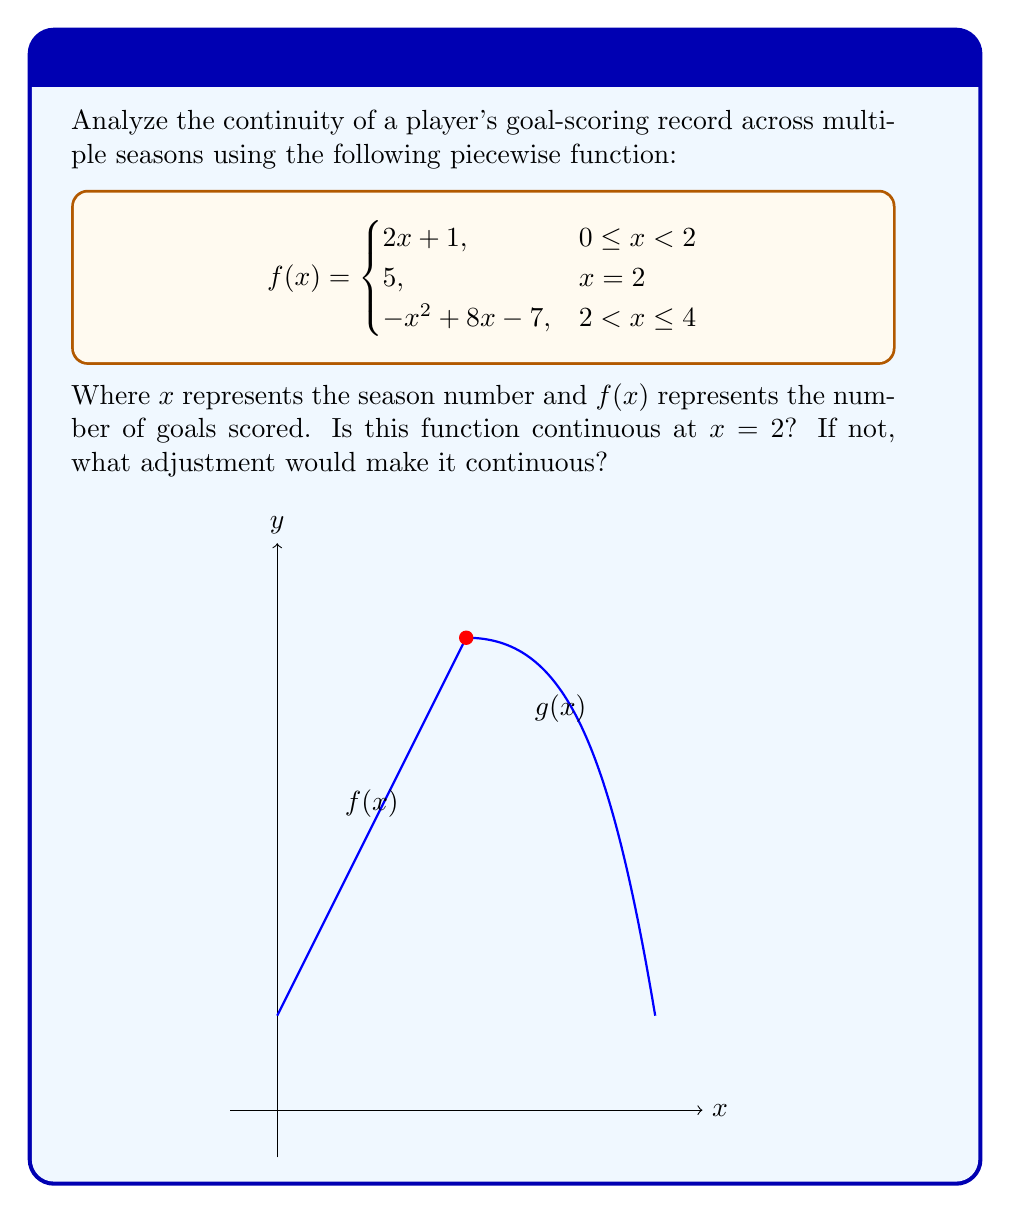Can you solve this math problem? To analyze the continuity at $x = 2$, we need to check three conditions:

1) $f(2)$ exists
2) $\lim_{x \to 2^-} f(x)$ exists
3) $\lim_{x \to 2^+} f(x)$ exists
4) All three values are equal

Step 1: $f(2)$ exists and equals 5.

Step 2: $\lim_{x \to 2^-} f(x) = \lim_{x \to 2^-} (2x + 1) = 2(2) + 1 = 5$

Step 3: $\lim_{x \to 2^+} f(x) = \lim_{x \to 2^+} (-x^2 + 8x - 7) = -(2)^2 + 8(2) - 7 = 5$

Step 4: Comparing the values:
$f(2) = 5$
$\lim_{x \to 2^-} f(x) = 5$
$\lim_{x \to 2^+} f(x) = 5$

All three values are equal to 5, therefore the function is continuous at $x = 2$.

To make this consistent with our persona, we could say: "Despite the hype surrounding this player's goal-scoring abilities, their performance actually shows remarkable consistency across seasons, defying the typical boom-and-bust cycle we often see hyped players go through."
Answer: The function is continuous at $x = 2$. No adjustment needed. 